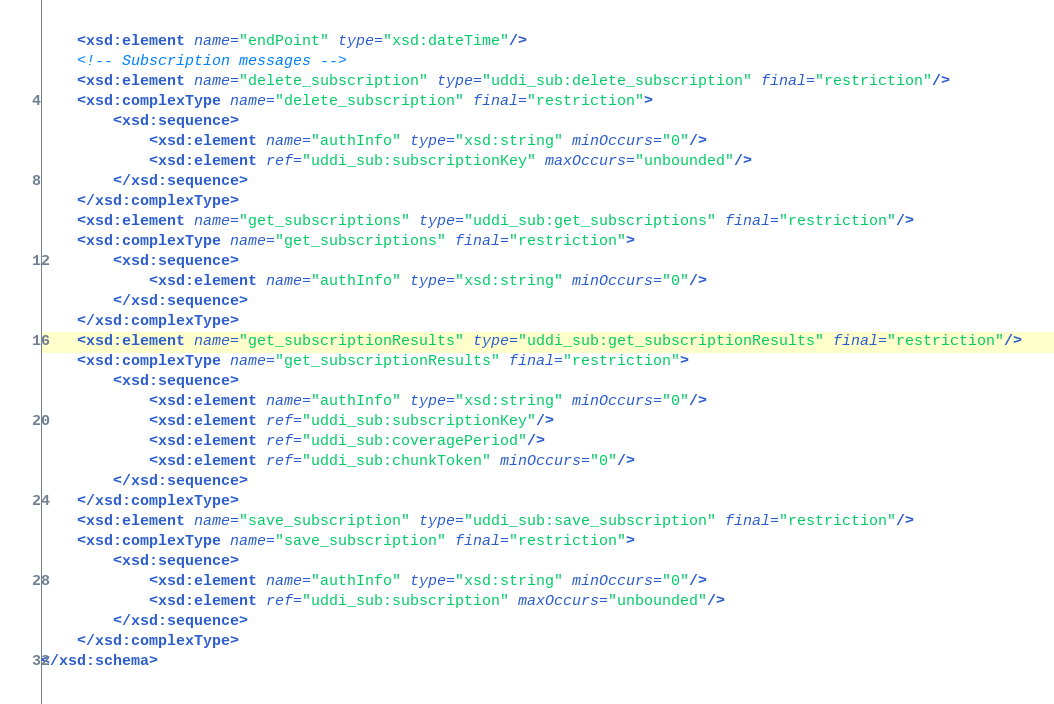<code> <loc_0><loc_0><loc_500><loc_500><_XML_>	<xsd:element name="endPoint" type="xsd:dateTime"/>
	<!-- Subscription messages -->
	<xsd:element name="delete_subscription" type="uddi_sub:delete_subscription" final="restriction"/>
	<xsd:complexType name="delete_subscription" final="restriction">
		<xsd:sequence>
			<xsd:element name="authInfo" type="xsd:string" minOccurs="0"/>
			<xsd:element ref="uddi_sub:subscriptionKey" maxOccurs="unbounded"/>
		</xsd:sequence>
	</xsd:complexType>
	<xsd:element name="get_subscriptions" type="uddi_sub:get_subscriptions" final="restriction"/>
	<xsd:complexType name="get_subscriptions" final="restriction">
		<xsd:sequence>
			<xsd:element name="authInfo" type="xsd:string" minOccurs="0"/>
		</xsd:sequence>
	</xsd:complexType>
	<xsd:element name="get_subscriptionResults" type="uddi_sub:get_subscriptionResults" final="restriction"/>
	<xsd:complexType name="get_subscriptionResults" final="restriction">
		<xsd:sequence>
			<xsd:element name="authInfo" type="xsd:string" minOccurs="0"/>
			<xsd:element ref="uddi_sub:subscriptionKey"/>
			<xsd:element ref="uddi_sub:coveragePeriod"/>
			<xsd:element ref="uddi_sub:chunkToken" minOccurs="0"/>
		</xsd:sequence>
	</xsd:complexType>
	<xsd:element name="save_subscription" type="uddi_sub:save_subscription" final="restriction"/>
	<xsd:complexType name="save_subscription" final="restriction">
		<xsd:sequence>
			<xsd:element name="authInfo" type="xsd:string" minOccurs="0"/>
			<xsd:element ref="uddi_sub:subscription" maxOccurs="unbounded"/>
		</xsd:sequence>
	</xsd:complexType>
</xsd:schema>
</code> 